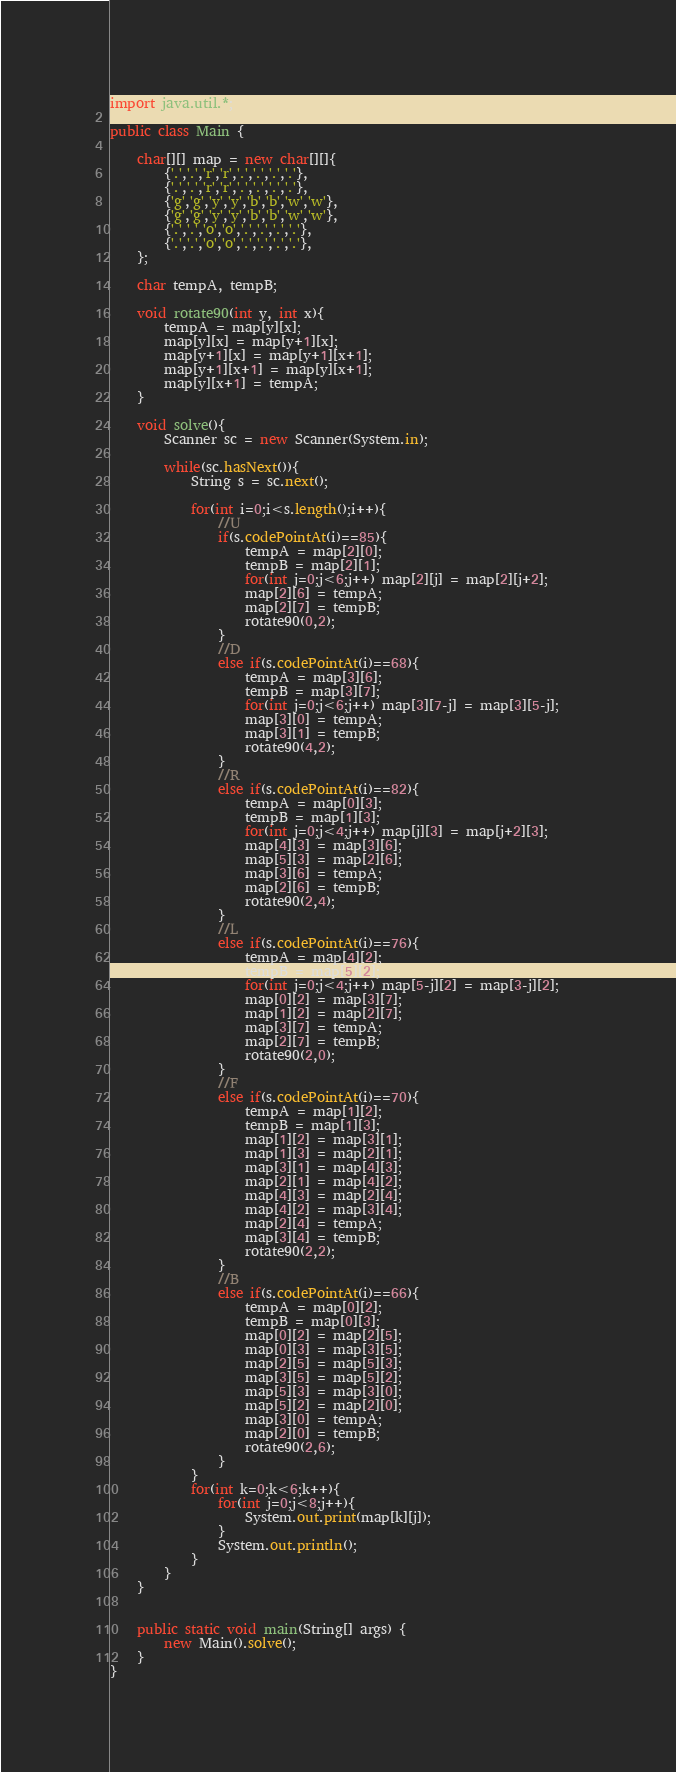<code> <loc_0><loc_0><loc_500><loc_500><_Java_>import java.util.*;

public class Main {

	char[][] map = new char[][]{
		{'.','.','r','r','.','.','.','.'},
		{'.','.','r','r','.','.','.','.'},
		{'g','g','y','y','b','b','w','w'},
		{'g','g','y','y','b','b','w','w'},
		{'.','.','o','o','.','.','.','.'},
		{'.','.','o','o','.','.','.','.'},	
	};
	
	char tempA, tempB;
	
	void rotate90(int y, int x){
		tempA = map[y][x];
		map[y][x] = map[y+1][x];
		map[y+1][x] = map[y+1][x+1];
		map[y+1][x+1] = map[y][x+1];
		map[y][x+1] = tempA;
	}

	void solve(){
		Scanner sc = new Scanner(System.in);
		
		while(sc.hasNext()){
			String s = sc.next();
			
			for(int i=0;i<s.length();i++){
				//U
				if(s.codePointAt(i)==85){
					tempA = map[2][0];
					tempB = map[2][1];
					for(int j=0;j<6;j++) map[2][j] = map[2][j+2];
					map[2][6] = tempA;
					map[2][7] = tempB;
					rotate90(0,2);
				}
				//D
				else if(s.codePointAt(i)==68){
					tempA = map[3][6];
					tempB = map[3][7];
					for(int j=0;j<6;j++) map[3][7-j] = map[3][5-j];
					map[3][0] = tempA;
					map[3][1] = tempB;
					rotate90(4,2);
				}
				//R
				else if(s.codePointAt(i)==82){
					tempA = map[0][3];
					tempB = map[1][3];
					for(int j=0;j<4;j++) map[j][3] = map[j+2][3];
					map[4][3] = map[3][6];
					map[5][3] = map[2][6];
					map[3][6] = tempA;
					map[2][6] = tempB;
					rotate90(2,4);
				}
				//L
				else if(s.codePointAt(i)==76){
					tempA = map[4][2];
					tempB = map[5][2];
					for(int j=0;j<4;j++) map[5-j][2] = map[3-j][2];
					map[0][2] = map[3][7];
					map[1][2] = map[2][7];
					map[3][7] = tempA;
					map[2][7] = tempB;
					rotate90(2,0);
				}
				//F
				else if(s.codePointAt(i)==70){						
					tempA = map[1][2];
					tempB = map[1][3];
					map[1][2] = map[3][1];
					map[1][3] = map[2][1];
					map[3][1] = map[4][3];
					map[2][1] = map[4][2];
					map[4][3] = map[2][4];
					map[4][2] = map[3][4];
					map[2][4] = tempA;
					map[3][4] = tempB;			
					rotate90(2,2);
				}
				//B
				else if(s.codePointAt(i)==66){						
					tempA = map[0][2];
					tempB = map[0][3];
					map[0][2] = map[2][5];
					map[0][3] = map[3][5];
					map[2][5] = map[5][3];
					map[3][5] = map[5][2];
					map[5][3] = map[3][0];
					map[5][2] = map[2][0];
					map[3][0] = tempA;
					map[2][0] = tempB;
					rotate90(2,6);
				}	
			}
			for(int k=0;k<6;k++){
				for(int j=0;j<8;j++){
					System.out.print(map[k][j]);
				}
				System.out.println();
			}
		}
	}
	
	
	public static void main(String[] args) {
		new Main().solve();
	}	
}</code> 